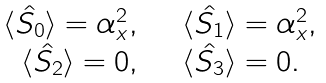Convert formula to latex. <formula><loc_0><loc_0><loc_500><loc_500>\begin{array} { r l } \langle \hat { S _ { 0 } } \rangle = { \alpha } ^ { 2 } _ { x } , & \quad \langle \hat { S _ { 1 } } \rangle = { \alpha } ^ { 2 } _ { x } , \\ \langle \hat { S _ { 2 } } \rangle = 0 , & \quad \langle \hat { S _ { 3 } } \rangle = 0 . \end{array}</formula> 